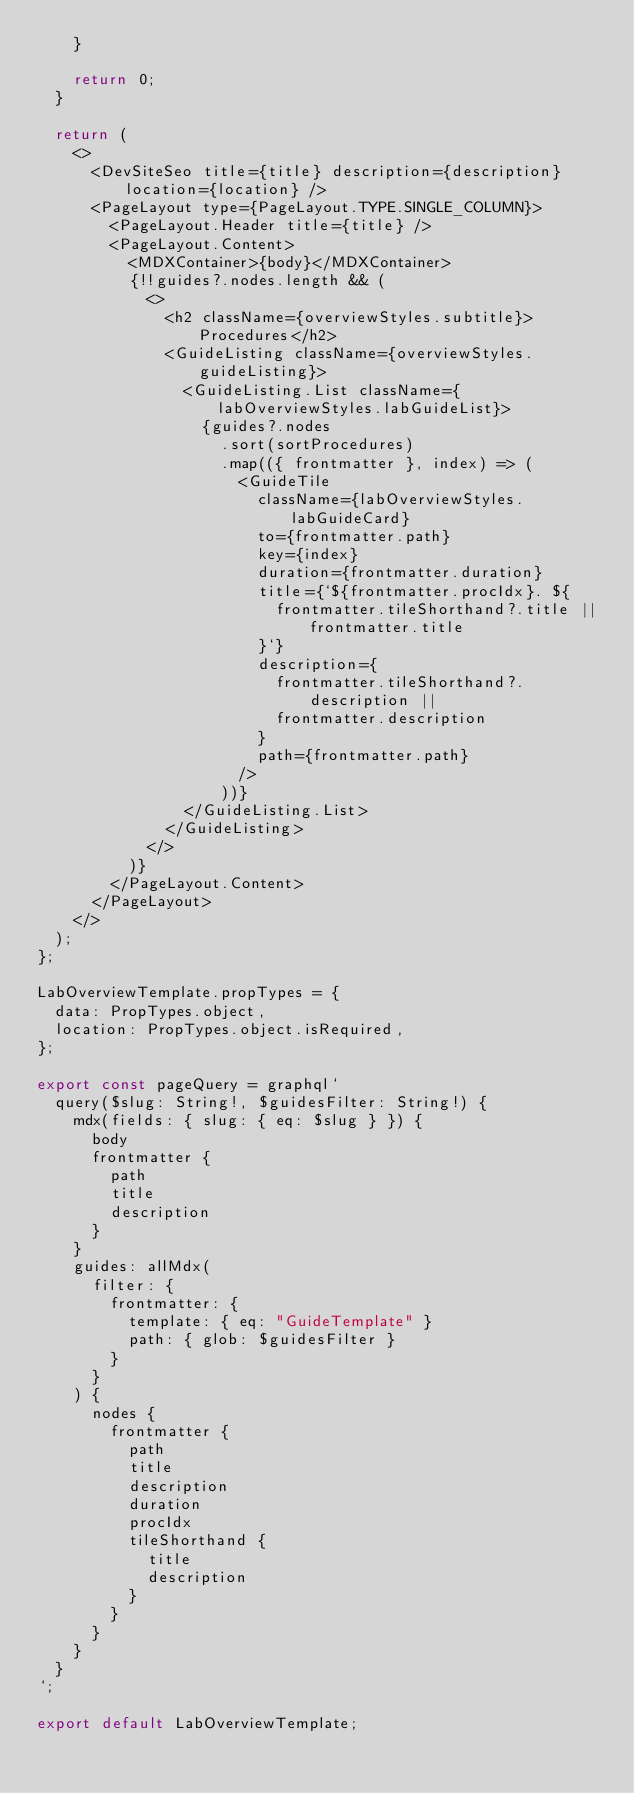<code> <loc_0><loc_0><loc_500><loc_500><_JavaScript_>    }

    return 0;
  }

  return (
    <>
      <DevSiteSeo title={title} description={description} location={location} />
      <PageLayout type={PageLayout.TYPE.SINGLE_COLUMN}>
        <PageLayout.Header title={title} />
        <PageLayout.Content>
          <MDXContainer>{body}</MDXContainer>
          {!!guides?.nodes.length && (
            <>
              <h2 className={overviewStyles.subtitle}>Procedures</h2>
              <GuideListing className={overviewStyles.guideListing}>
                <GuideListing.List className={labOverviewStyles.labGuideList}>
                  {guides?.nodes
                    .sort(sortProcedures)
                    .map(({ frontmatter }, index) => (
                      <GuideTile
                        className={labOverviewStyles.labGuideCard}
                        to={frontmatter.path}
                        key={index}
                        duration={frontmatter.duration}
                        title={`${frontmatter.procIdx}. ${
                          frontmatter.tileShorthand?.title || frontmatter.title
                        }`}
                        description={
                          frontmatter.tileShorthand?.description ||
                          frontmatter.description
                        }
                        path={frontmatter.path}
                      />
                    ))}
                </GuideListing.List>
              </GuideListing>
            </>
          )}
        </PageLayout.Content>
      </PageLayout>
    </>
  );
};

LabOverviewTemplate.propTypes = {
  data: PropTypes.object,
  location: PropTypes.object.isRequired,
};

export const pageQuery = graphql`
  query($slug: String!, $guidesFilter: String!) {
    mdx(fields: { slug: { eq: $slug } }) {
      body
      frontmatter {
        path
        title
        description
      }
    }
    guides: allMdx(
      filter: {
        frontmatter: {
          template: { eq: "GuideTemplate" }
          path: { glob: $guidesFilter }
        }
      }
    ) {
      nodes {
        frontmatter {
          path
          title
          description
          duration
          procIdx
          tileShorthand {
            title
            description
          }
        }
      }
    }
  }
`;

export default LabOverviewTemplate;
</code> 